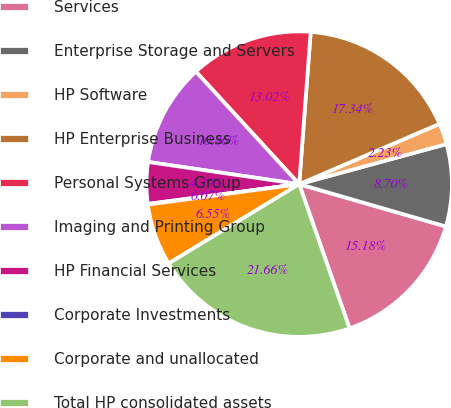Convert chart. <chart><loc_0><loc_0><loc_500><loc_500><pie_chart><fcel>Services<fcel>Enterprise Storage and Servers<fcel>HP Software<fcel>HP Enterprise Business<fcel>Personal Systems Group<fcel>Imaging and Printing Group<fcel>HP Financial Services<fcel>Corporate Investments<fcel>Corporate and unallocated<fcel>Total HP consolidated assets<nl><fcel>15.18%<fcel>8.7%<fcel>2.23%<fcel>17.34%<fcel>13.02%<fcel>10.86%<fcel>4.39%<fcel>0.07%<fcel>6.55%<fcel>21.66%<nl></chart> 